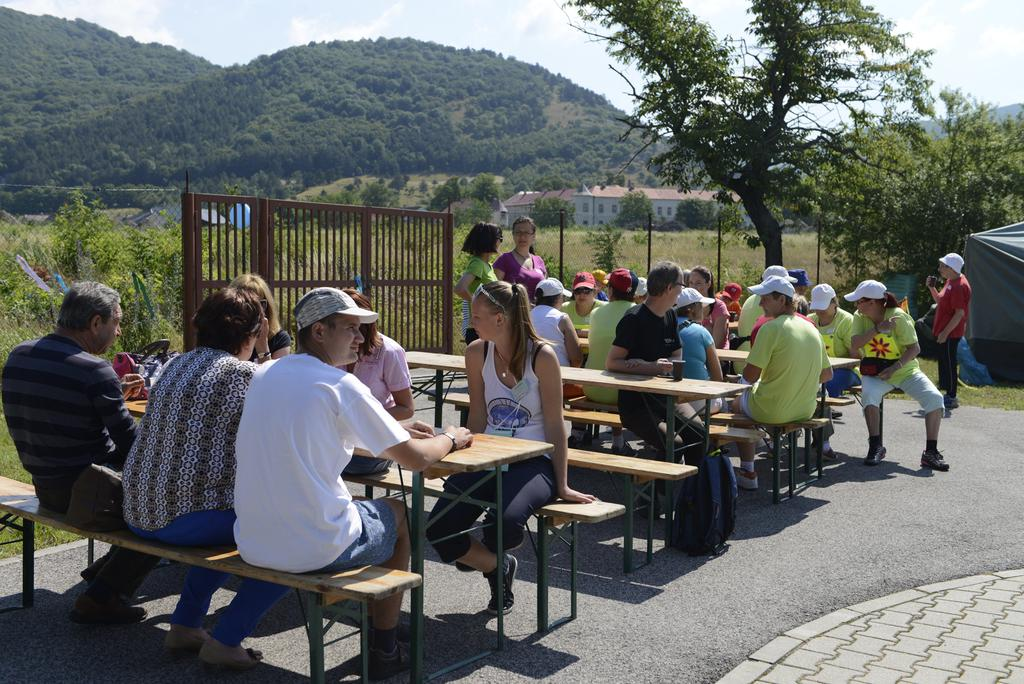What are the people in the image sitting on? There is a group of people sitting on wooden chairs in the image. What type of fence can be seen in the image? There is a metal fence in the image. What natural element is present in the image? There is a tree in the image. What can be seen in the distance in the image? There is a mountain in the background of the image. What is visible in the sky in the image? The sky with clouds is visible in the background of the image. How many bats are hanging from the tree in the image? There are no bats hanging from the tree in the image. 